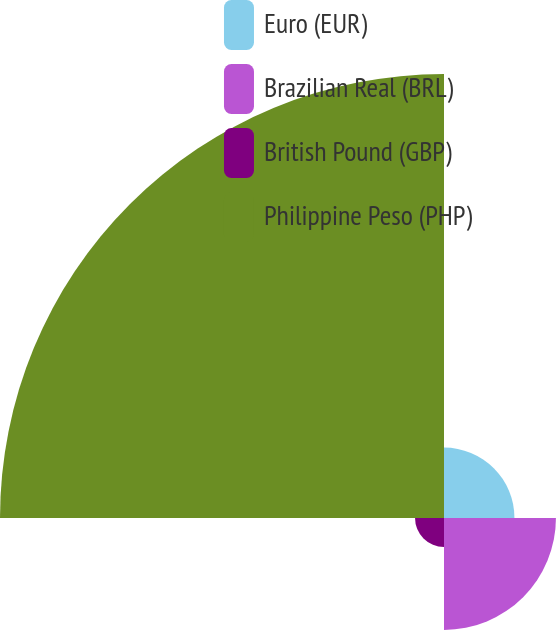Convert chart to OTSL. <chart><loc_0><loc_0><loc_500><loc_500><pie_chart><fcel>Euro (EUR)<fcel>Brazilian Real (BRL)<fcel>British Pound (GBP)<fcel>Philippine Peso (PHP)<nl><fcel>10.75%<fcel>17.08%<fcel>4.42%<fcel>67.75%<nl></chart> 